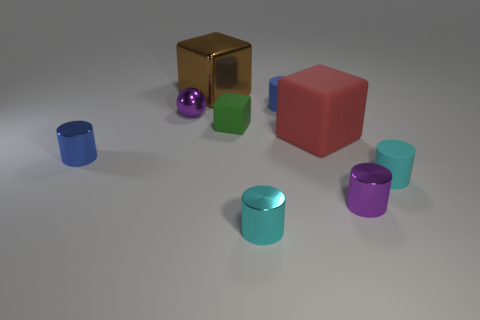Subtract all purple cylinders. How many cylinders are left? 4 Subtract all cyan rubber cylinders. How many cylinders are left? 4 Subtract all yellow cylinders. Subtract all brown blocks. How many cylinders are left? 5 Add 1 big red spheres. How many objects exist? 10 Subtract all cylinders. How many objects are left? 4 Add 7 tiny green rubber things. How many tiny green rubber things exist? 8 Subtract 1 blue cylinders. How many objects are left? 8 Subtract all small purple metal blocks. Subtract all purple metal objects. How many objects are left? 7 Add 3 big rubber objects. How many big rubber objects are left? 4 